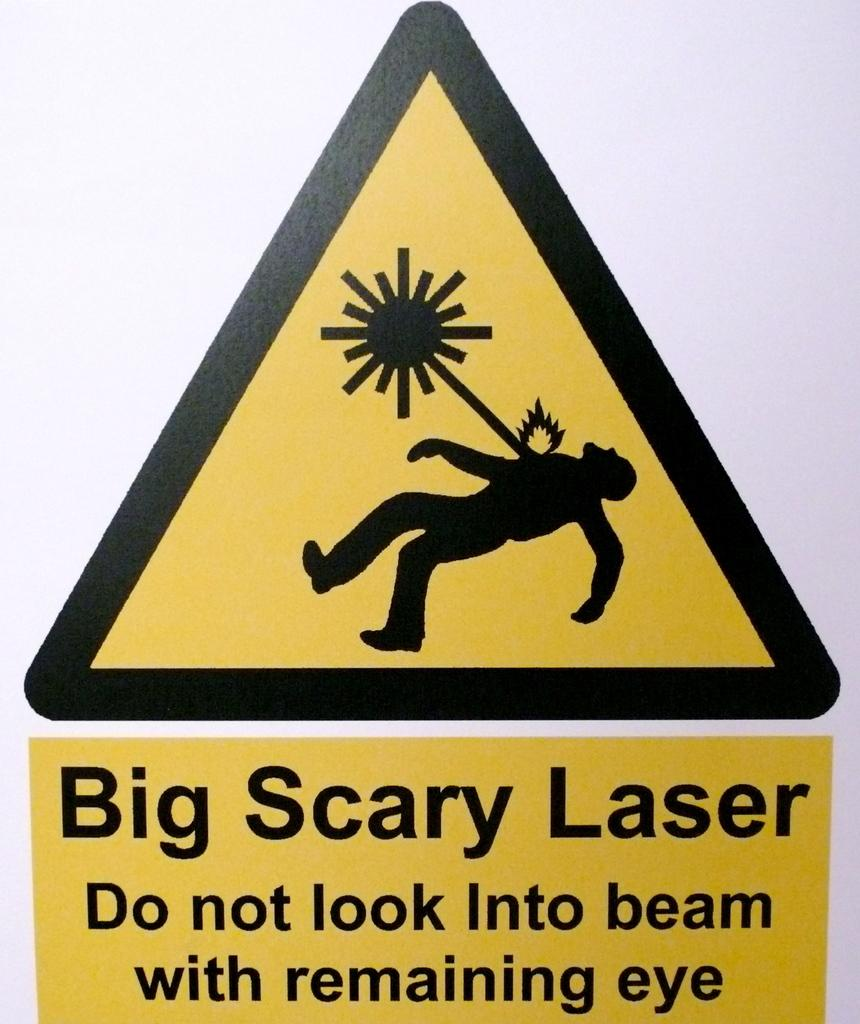Provide a one-sentence caption for the provided image. A humorous sign warning against looking into a laser beam. 